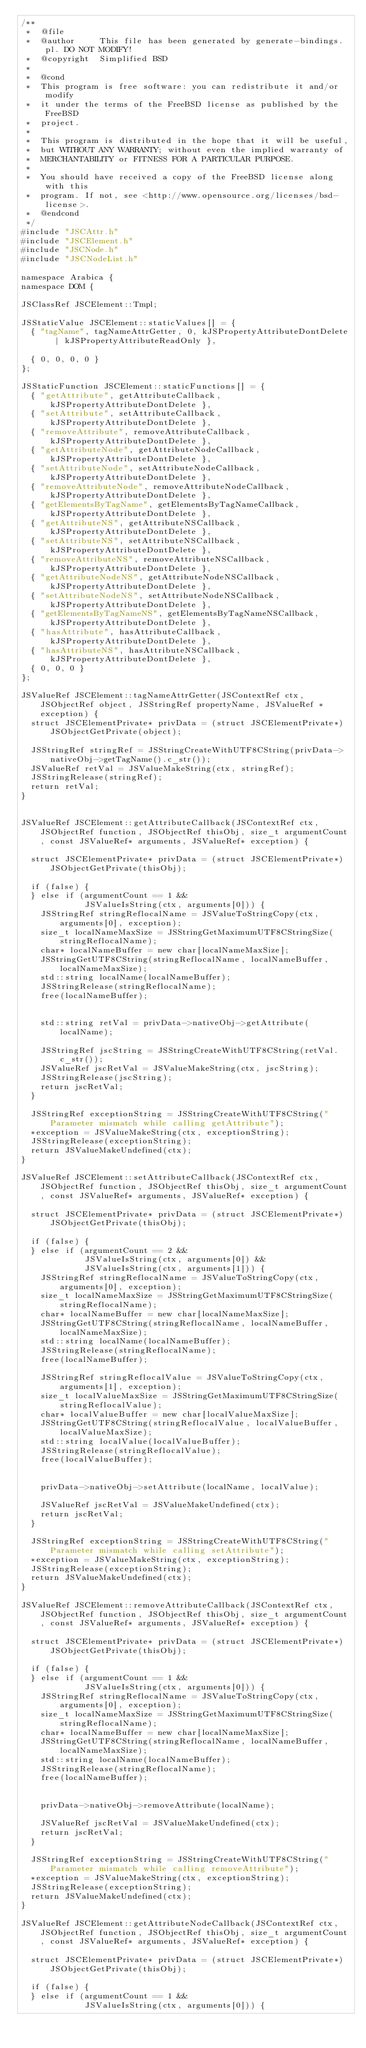Convert code to text. <code><loc_0><loc_0><loc_500><loc_500><_C++_>/**
 *  @file
 *  @author     This file has been generated by generate-bindings.pl. DO NOT MODIFY!
 *  @copyright  Simplified BSD
 *
 *  @cond
 *  This program is free software: you can redistribute it and/or modify
 *  it under the terms of the FreeBSD license as published by the FreeBSD
 *  project.
 *
 *  This program is distributed in the hope that it will be useful,
 *  but WITHOUT ANY WARRANTY; without even the implied warranty of
 *  MERCHANTABILITY or FITNESS FOR A PARTICULAR PURPOSE.
 *
 *  You should have received a copy of the FreeBSD license along with this
 *  program. If not, see <http://www.opensource.org/licenses/bsd-license>.
 *  @endcond
 */
#include "JSCAttr.h"
#include "JSCElement.h"
#include "JSCNode.h"
#include "JSCNodeList.h"

namespace Arabica {
namespace DOM {

JSClassRef JSCElement::Tmpl;

JSStaticValue JSCElement::staticValues[] = {
	{ "tagName", tagNameAttrGetter, 0, kJSPropertyAttributeDontDelete | kJSPropertyAttributeReadOnly },

	{ 0, 0, 0, 0 }
};

JSStaticFunction JSCElement::staticFunctions[] = {
	{ "getAttribute", getAttributeCallback, kJSPropertyAttributeDontDelete },
	{ "setAttribute", setAttributeCallback, kJSPropertyAttributeDontDelete },
	{ "removeAttribute", removeAttributeCallback, kJSPropertyAttributeDontDelete },
	{ "getAttributeNode", getAttributeNodeCallback, kJSPropertyAttributeDontDelete },
	{ "setAttributeNode", setAttributeNodeCallback, kJSPropertyAttributeDontDelete },
	{ "removeAttributeNode", removeAttributeNodeCallback, kJSPropertyAttributeDontDelete },
	{ "getElementsByTagName", getElementsByTagNameCallback, kJSPropertyAttributeDontDelete },
	{ "getAttributeNS", getAttributeNSCallback, kJSPropertyAttributeDontDelete },
	{ "setAttributeNS", setAttributeNSCallback, kJSPropertyAttributeDontDelete },
	{ "removeAttributeNS", removeAttributeNSCallback, kJSPropertyAttributeDontDelete },
	{ "getAttributeNodeNS", getAttributeNodeNSCallback, kJSPropertyAttributeDontDelete },
	{ "setAttributeNodeNS", setAttributeNodeNSCallback, kJSPropertyAttributeDontDelete },
	{ "getElementsByTagNameNS", getElementsByTagNameNSCallback, kJSPropertyAttributeDontDelete },
	{ "hasAttribute", hasAttributeCallback, kJSPropertyAttributeDontDelete },
	{ "hasAttributeNS", hasAttributeNSCallback, kJSPropertyAttributeDontDelete },
	{ 0, 0, 0 }
};

JSValueRef JSCElement::tagNameAttrGetter(JSContextRef ctx, JSObjectRef object, JSStringRef propertyName, JSValueRef *exception) {
	struct JSCElementPrivate* privData = (struct JSCElementPrivate*)JSObjectGetPrivate(object);

	JSStringRef stringRef = JSStringCreateWithUTF8CString(privData->nativeObj->getTagName().c_str());
	JSValueRef retVal = JSValueMakeString(ctx, stringRef);
	JSStringRelease(stringRef);
	return retVal;
}


JSValueRef JSCElement::getAttributeCallback(JSContextRef ctx, JSObjectRef function, JSObjectRef thisObj, size_t argumentCount, const JSValueRef* arguments, JSValueRef* exception) {

	struct JSCElementPrivate* privData = (struct JSCElementPrivate*)JSObjectGetPrivate(thisObj);

	if (false) {
	} else if (argumentCount == 1 &&
	           JSValueIsString(ctx, arguments[0])) {
		JSStringRef stringReflocalName = JSValueToStringCopy(ctx, arguments[0], exception);
		size_t localNameMaxSize = JSStringGetMaximumUTF8CStringSize(stringReflocalName);
		char* localNameBuffer = new char[localNameMaxSize];
		JSStringGetUTF8CString(stringReflocalName, localNameBuffer, localNameMaxSize);
		std::string localName(localNameBuffer);
		JSStringRelease(stringReflocalName);
		free(localNameBuffer);


		std::string retVal = privData->nativeObj->getAttribute(localName);

		JSStringRef jscString = JSStringCreateWithUTF8CString(retVal.c_str());
		JSValueRef jscRetVal = JSValueMakeString(ctx, jscString);
		JSStringRelease(jscString);
		return jscRetVal;
	}

	JSStringRef exceptionString = JSStringCreateWithUTF8CString("Parameter mismatch while calling getAttribute");
	*exception = JSValueMakeString(ctx, exceptionString);
	JSStringRelease(exceptionString);
	return JSValueMakeUndefined(ctx);
}

JSValueRef JSCElement::setAttributeCallback(JSContextRef ctx, JSObjectRef function, JSObjectRef thisObj, size_t argumentCount, const JSValueRef* arguments, JSValueRef* exception) {

	struct JSCElementPrivate* privData = (struct JSCElementPrivate*)JSObjectGetPrivate(thisObj);

	if (false) {
	} else if (argumentCount == 2 &&
	           JSValueIsString(ctx, arguments[0]) &&
	           JSValueIsString(ctx, arguments[1])) {
		JSStringRef stringReflocalName = JSValueToStringCopy(ctx, arguments[0], exception);
		size_t localNameMaxSize = JSStringGetMaximumUTF8CStringSize(stringReflocalName);
		char* localNameBuffer = new char[localNameMaxSize];
		JSStringGetUTF8CString(stringReflocalName, localNameBuffer, localNameMaxSize);
		std::string localName(localNameBuffer);
		JSStringRelease(stringReflocalName);
		free(localNameBuffer);

		JSStringRef stringReflocalValue = JSValueToStringCopy(ctx, arguments[1], exception);
		size_t localValueMaxSize = JSStringGetMaximumUTF8CStringSize(stringReflocalValue);
		char* localValueBuffer = new char[localValueMaxSize];
		JSStringGetUTF8CString(stringReflocalValue, localValueBuffer, localValueMaxSize);
		std::string localValue(localValueBuffer);
		JSStringRelease(stringReflocalValue);
		free(localValueBuffer);


		privData->nativeObj->setAttribute(localName, localValue);

		JSValueRef jscRetVal = JSValueMakeUndefined(ctx);
		return jscRetVal;
	}

	JSStringRef exceptionString = JSStringCreateWithUTF8CString("Parameter mismatch while calling setAttribute");
	*exception = JSValueMakeString(ctx, exceptionString);
	JSStringRelease(exceptionString);
	return JSValueMakeUndefined(ctx);
}

JSValueRef JSCElement::removeAttributeCallback(JSContextRef ctx, JSObjectRef function, JSObjectRef thisObj, size_t argumentCount, const JSValueRef* arguments, JSValueRef* exception) {

	struct JSCElementPrivate* privData = (struct JSCElementPrivate*)JSObjectGetPrivate(thisObj);

	if (false) {
	} else if (argumentCount == 1 &&
	           JSValueIsString(ctx, arguments[0])) {
		JSStringRef stringReflocalName = JSValueToStringCopy(ctx, arguments[0], exception);
		size_t localNameMaxSize = JSStringGetMaximumUTF8CStringSize(stringReflocalName);
		char* localNameBuffer = new char[localNameMaxSize];
		JSStringGetUTF8CString(stringReflocalName, localNameBuffer, localNameMaxSize);
		std::string localName(localNameBuffer);
		JSStringRelease(stringReflocalName);
		free(localNameBuffer);


		privData->nativeObj->removeAttribute(localName);

		JSValueRef jscRetVal = JSValueMakeUndefined(ctx);
		return jscRetVal;
	}

	JSStringRef exceptionString = JSStringCreateWithUTF8CString("Parameter mismatch while calling removeAttribute");
	*exception = JSValueMakeString(ctx, exceptionString);
	JSStringRelease(exceptionString);
	return JSValueMakeUndefined(ctx);
}

JSValueRef JSCElement::getAttributeNodeCallback(JSContextRef ctx, JSObjectRef function, JSObjectRef thisObj, size_t argumentCount, const JSValueRef* arguments, JSValueRef* exception) {

	struct JSCElementPrivate* privData = (struct JSCElementPrivate*)JSObjectGetPrivate(thisObj);

	if (false) {
	} else if (argumentCount == 1 &&
	           JSValueIsString(ctx, arguments[0])) {</code> 